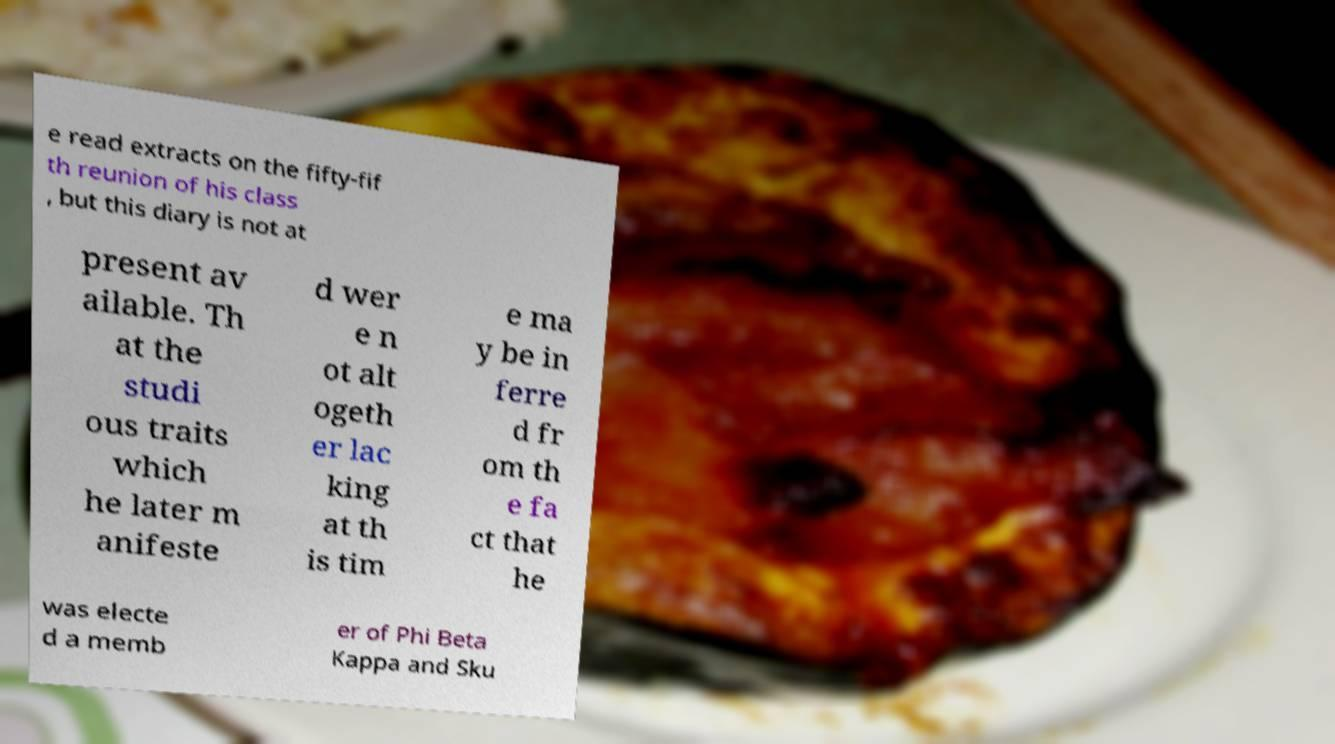Could you assist in decoding the text presented in this image and type it out clearly? e read extracts on the fifty-fif th reunion of his class , but this diary is not at present av ailable. Th at the studi ous traits which he later m anifeste d wer e n ot alt ogeth er lac king at th is tim e ma y be in ferre d fr om th e fa ct that he was electe d a memb er of Phi Beta Kappa and Sku 